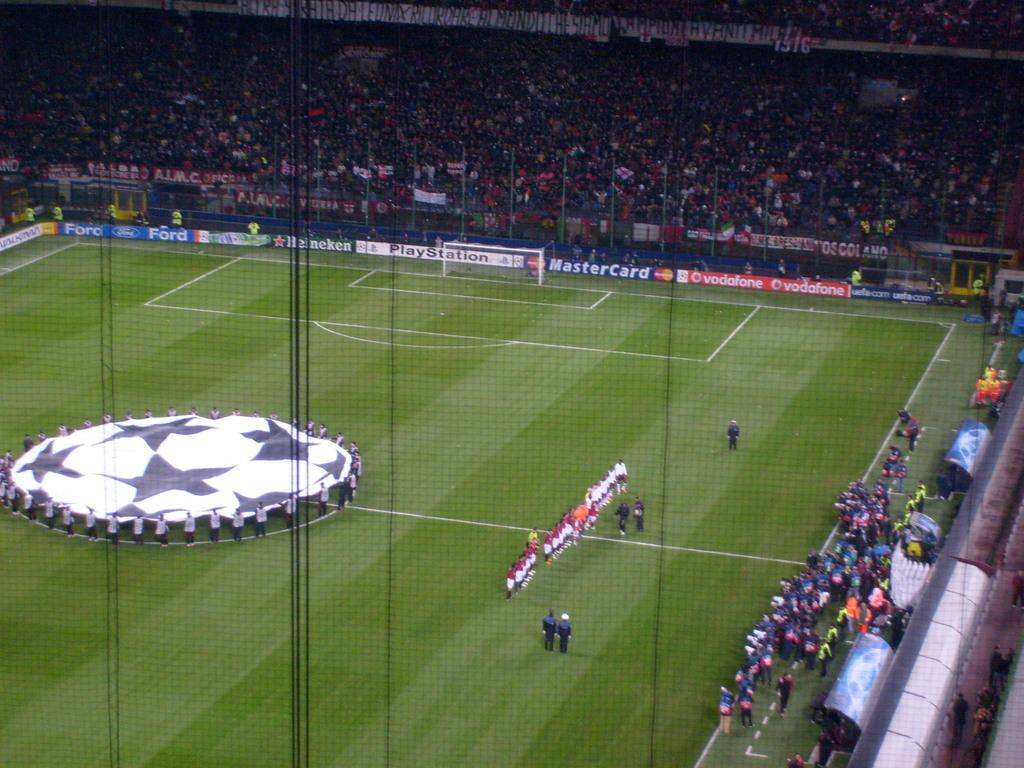Provide a one-sentence caption for the provided image. Mastercard advertises at a large soccer stadium that's filled with players and spectators. 